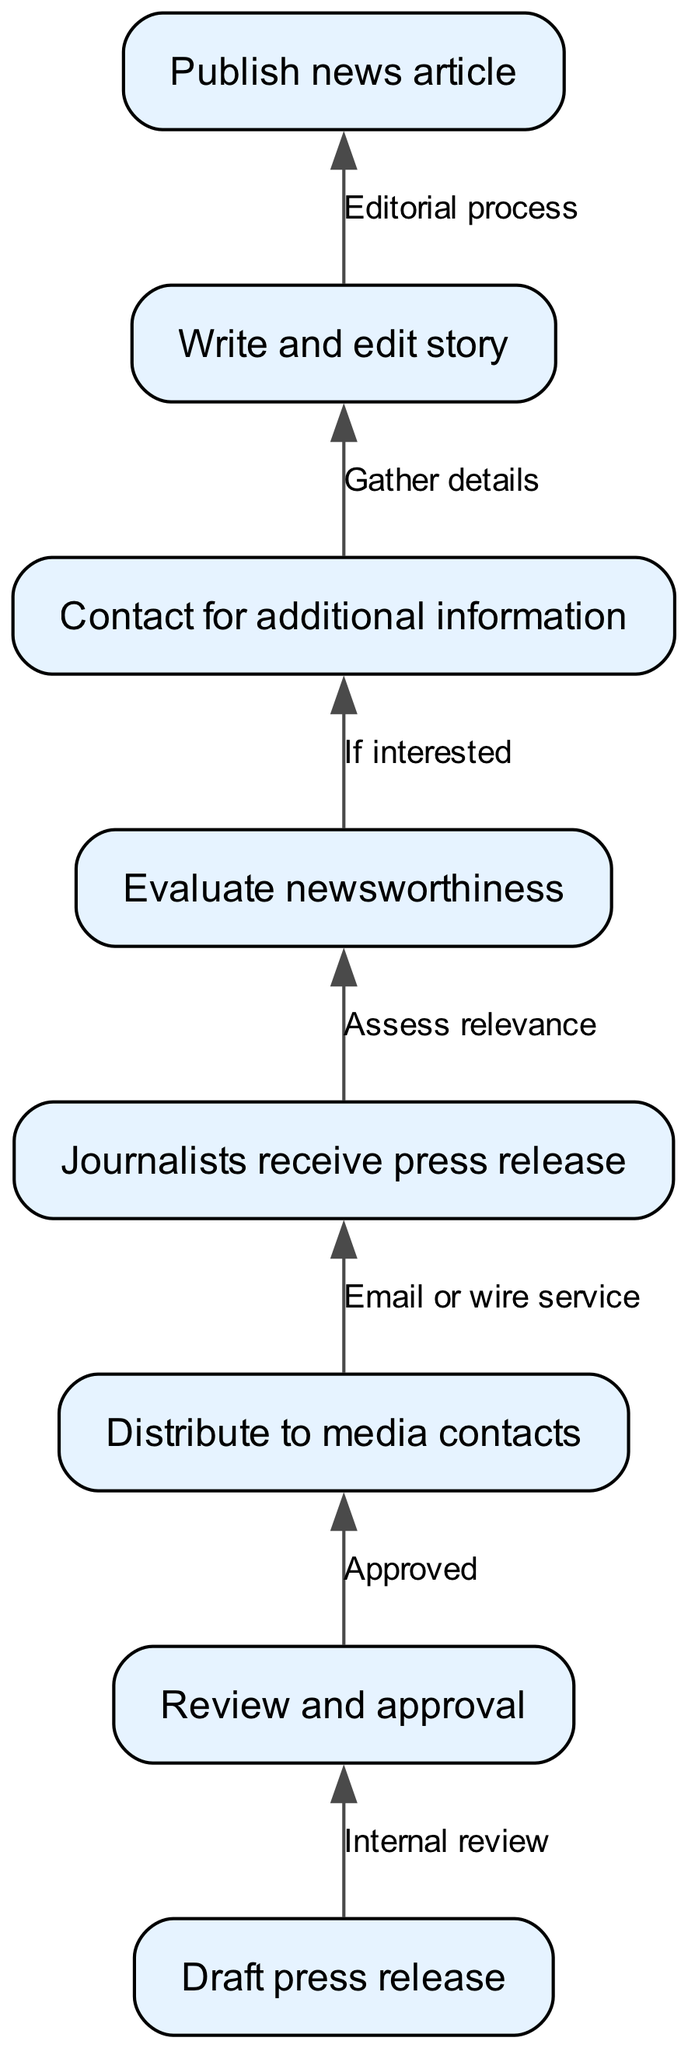What is the first step in the press release journey? The first node in the diagram is "Draft press release," which indicates that creating a press release is the initial step in the journey.
Answer: Draft press release How many nodes are there in the diagram? The diagram lists a total of eight nodes, representing different steps in the press release process.
Answer: 8 What happens after the "Review and approval" step? The edge leading from "Review and approval" points to "Distribute to media contacts," signifying that once the press release is approved, it is then distributed.
Answer: Distribute to media contacts Which node follows "Evaluate newsworthiness"? After "Evaluate newsworthiness," the diagram shows an edge connecting it to "Contact for additional information," indicating that if the press release is deemed interesting, journalists might reach out for further details.
Answer: Contact for additional information What is the relationship between "Journalists receive press release" and "Evaluate newsworthiness"? The edge connects these two nodes, with a label "Assess relevance," indicating that the journalists receive the press release and then assess its relevance before proceeding further.
Answer: Assess relevance What does the "Write and edit story" step follow? The "Write and edit story" step follows the "Contact for additional information" step, suggesting that journalists will write and refine their story after gathering necessary details.
Answer: Contact for additional information What is the final output of the press release process? The last node in the flow is "Publish news article," which is the end result of the press release journey after it has gone through all previous steps.
Answer: Publish news article What is the edge label between "Distribute to media contacts" and "Journalists receive press release"? The edge label indicates the method of distribution, which is "Email or wire service," explaining how the press release is sent to journalists.
Answer: Email or wire service 